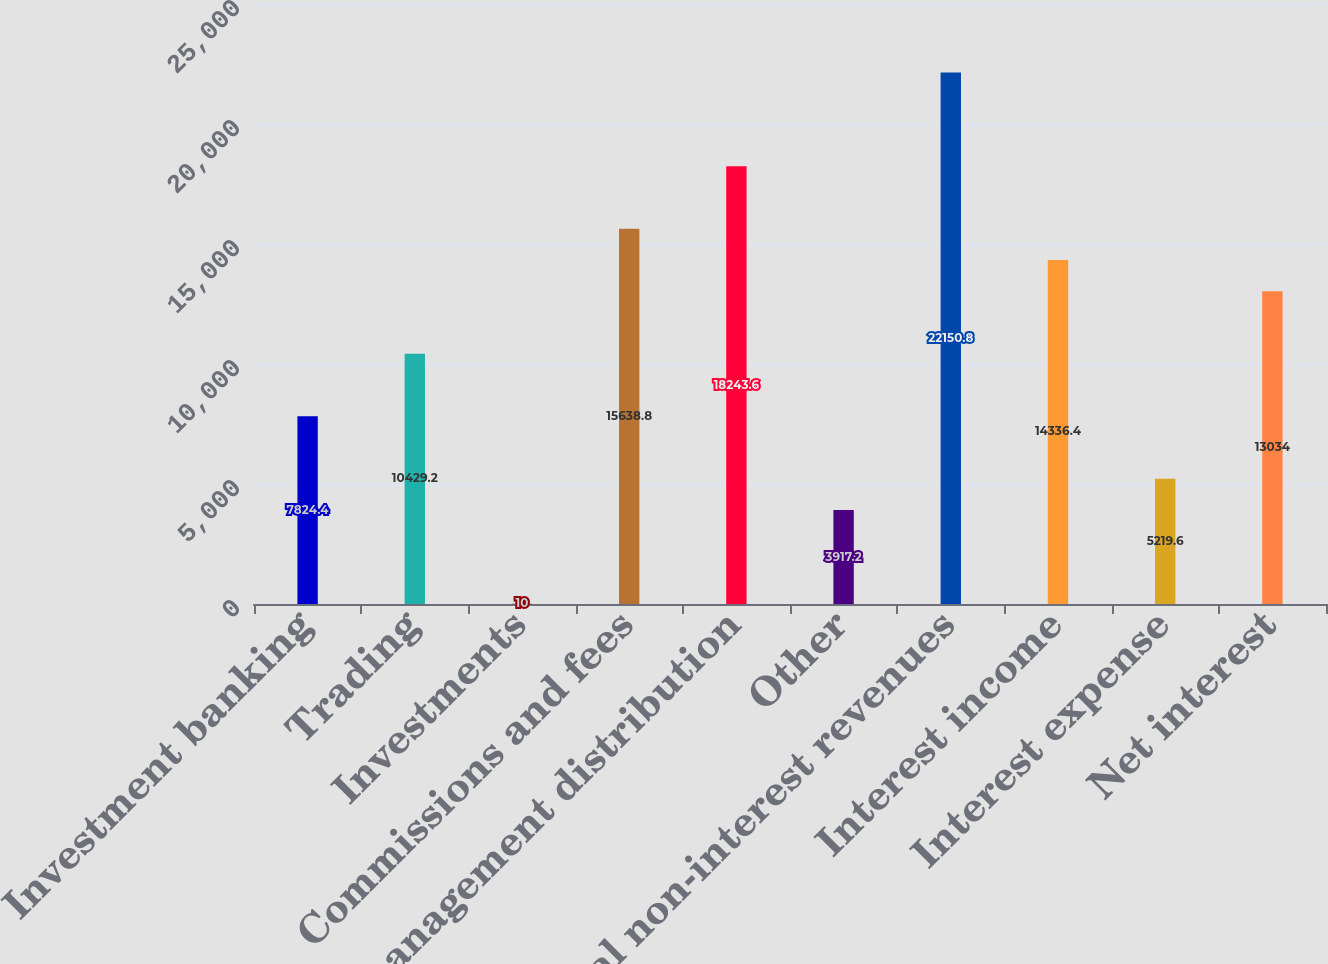<chart> <loc_0><loc_0><loc_500><loc_500><bar_chart><fcel>Investment banking<fcel>Trading<fcel>Investments<fcel>Commissions and fees<fcel>Asset management distribution<fcel>Other<fcel>Total non-interest revenues<fcel>Interest income<fcel>Interest expense<fcel>Net interest<nl><fcel>7824.4<fcel>10429.2<fcel>10<fcel>15638.8<fcel>18243.6<fcel>3917.2<fcel>22150.8<fcel>14336.4<fcel>5219.6<fcel>13034<nl></chart> 